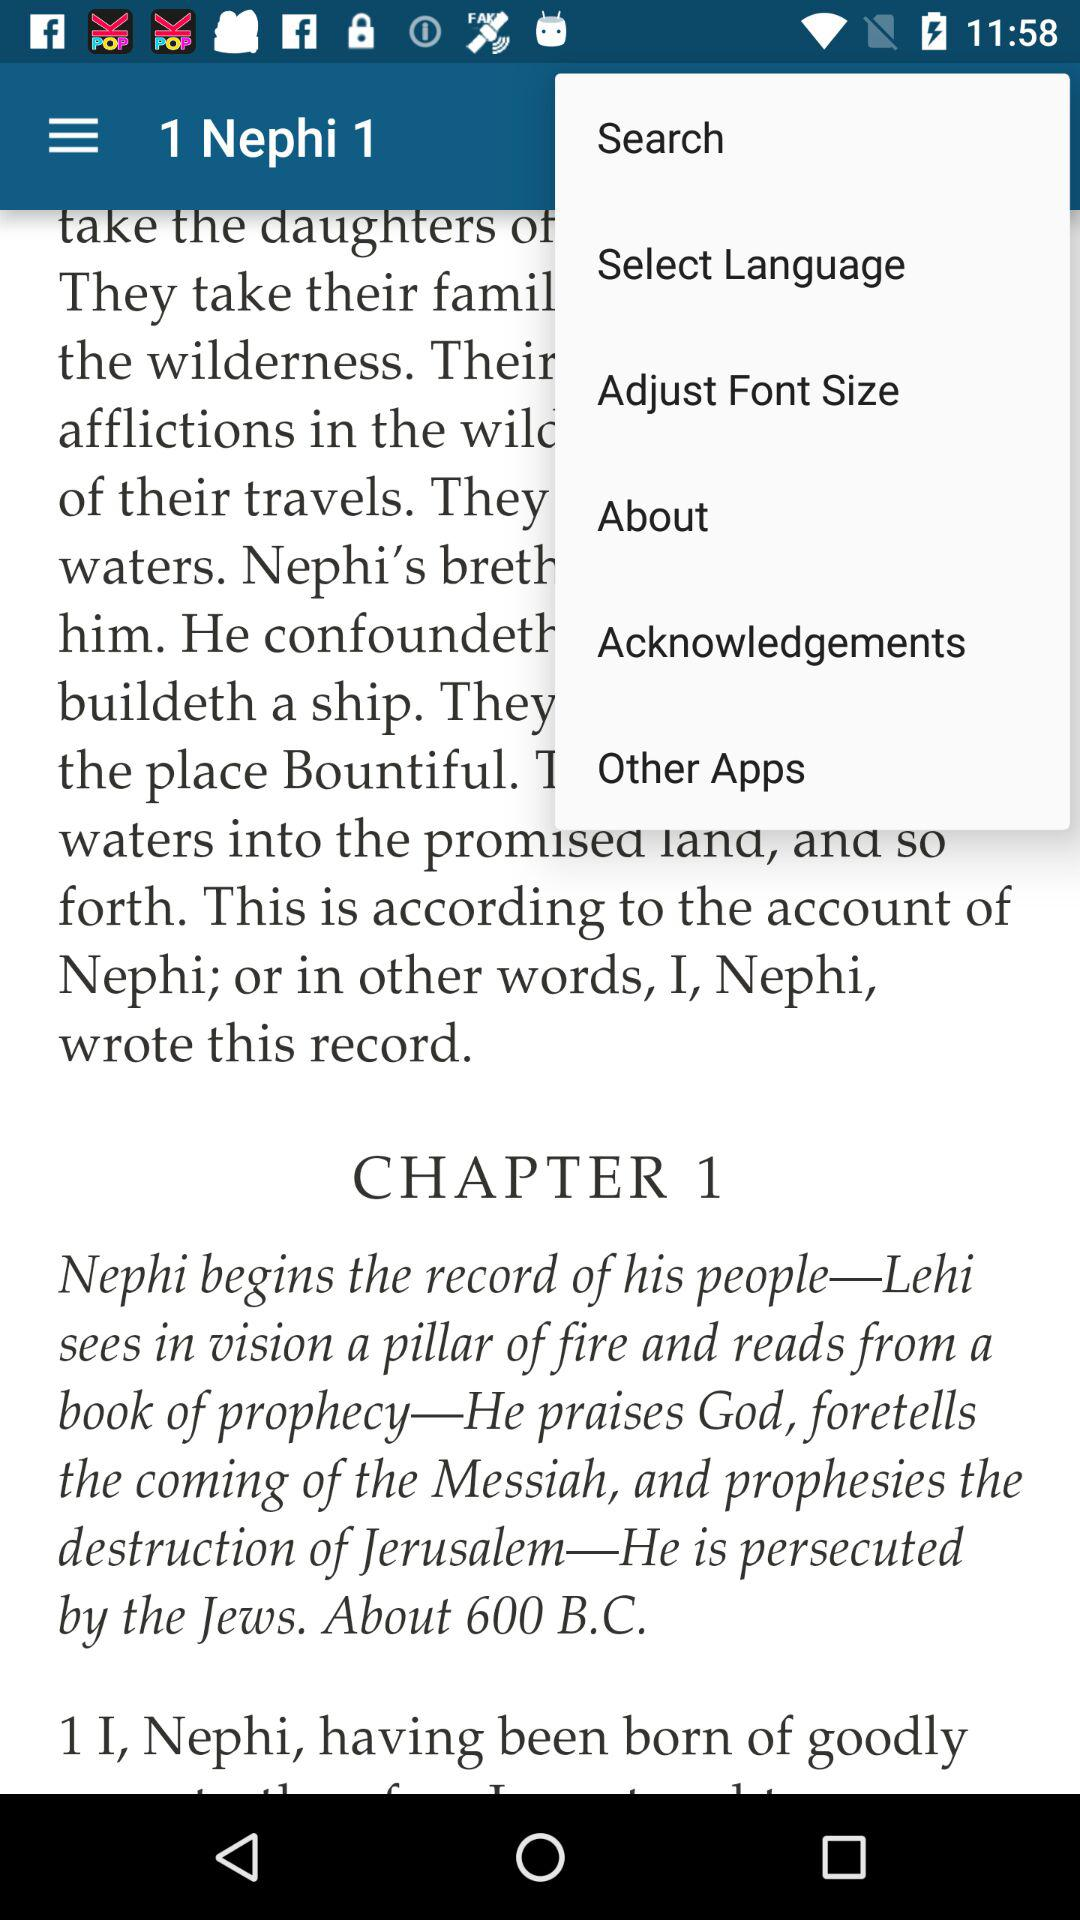What is the chapter number? The chapter number is 1. 